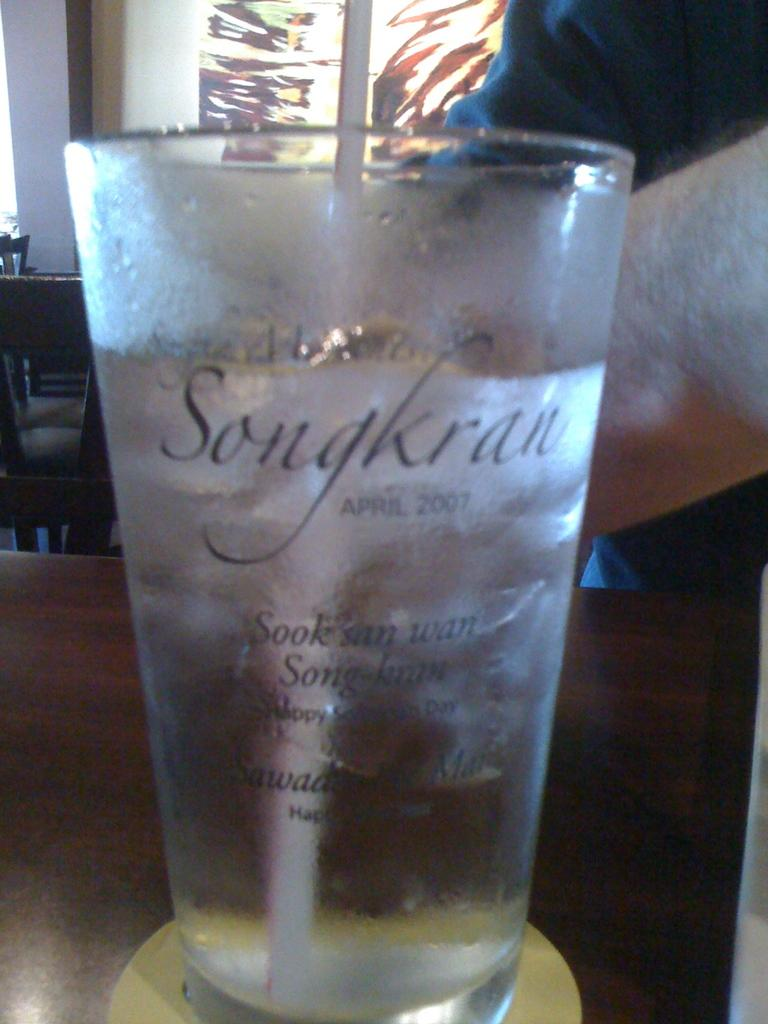<image>
Give a short and clear explanation of the subsequent image. A glass cup with the words Songkran April 2007 filled with ice water and a straw 